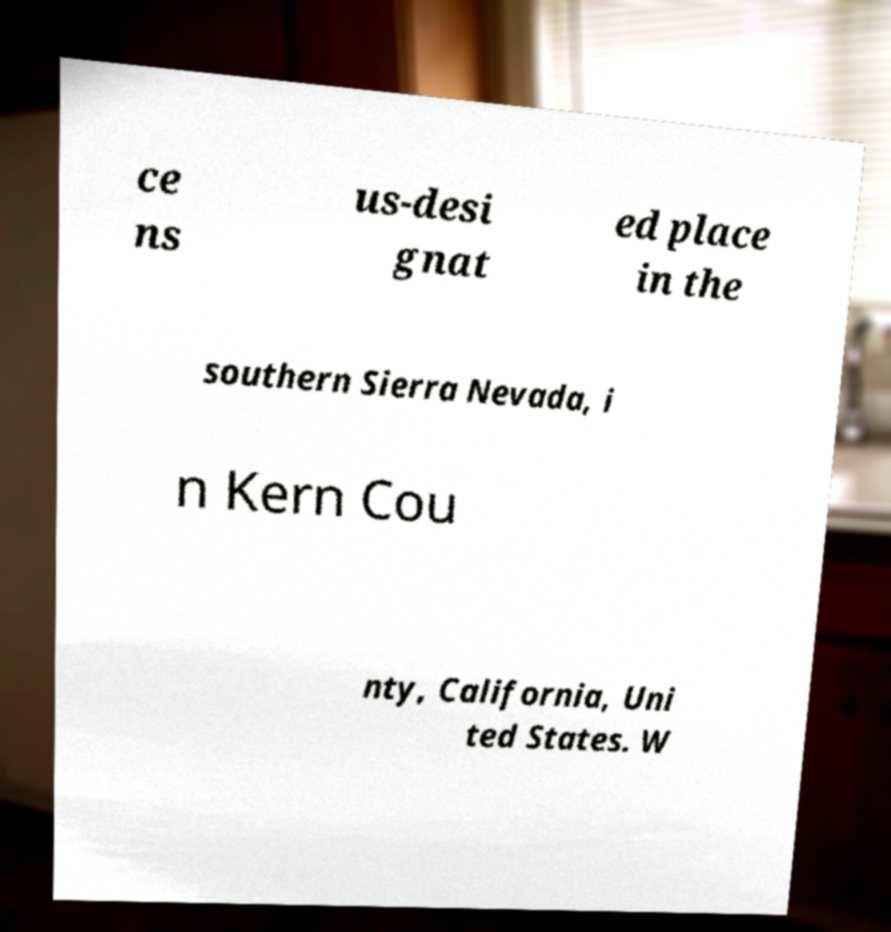Please identify and transcribe the text found in this image. ce ns us-desi gnat ed place in the southern Sierra Nevada, i n Kern Cou nty, California, Uni ted States. W 